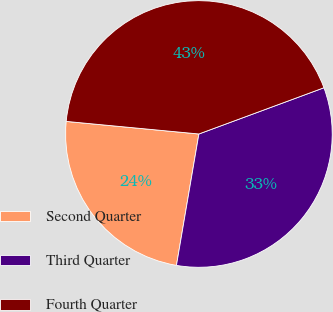<chart> <loc_0><loc_0><loc_500><loc_500><pie_chart><fcel>Second Quarter<fcel>Third Quarter<fcel>Fourth Quarter<nl><fcel>23.81%<fcel>33.33%<fcel>42.86%<nl></chart> 